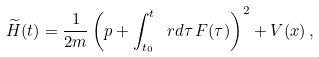<formula> <loc_0><loc_0><loc_500><loc_500>\widetilde { H } ( t ) = \frac { 1 } { 2 m } \left ( p + \int _ { t _ { 0 } } ^ { t } \, \ r d \tau \, F ( \tau ) \right ) ^ { 2 } + V ( x ) \, ,</formula> 